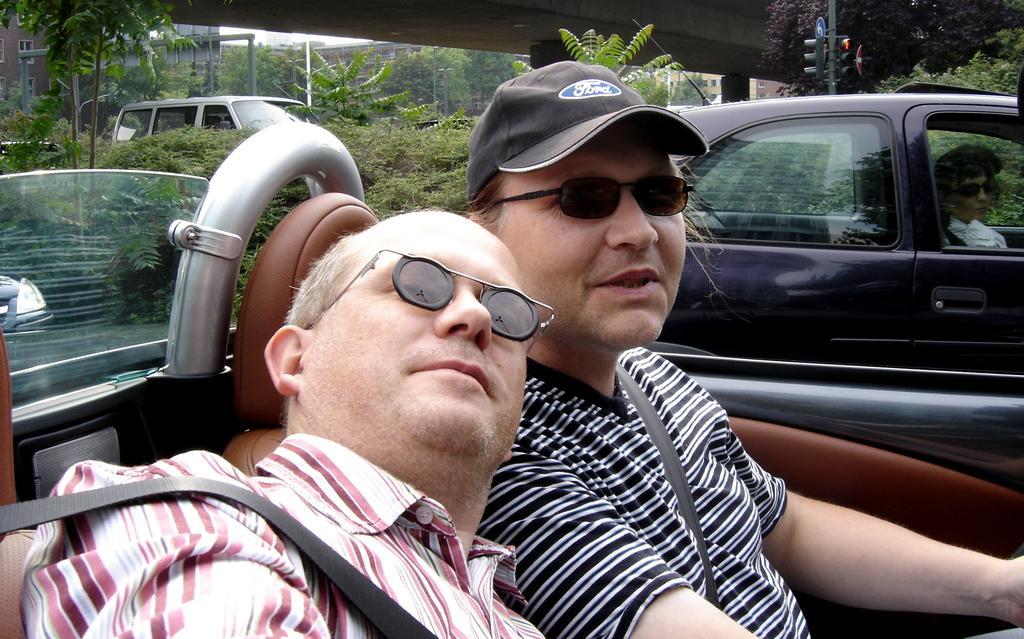Please provide a concise description of this image. In this image there are two persons who are sitting on a vehicle it seems that they are riding a vehicle and on the right side there is one person who is sitting and he is wearing a black shirt and goggles and cap on the left side there is another person who is sitting and he is wearing goggles on the top of the right side of the image there is one car and in that car there is one woman and on the left side of the image there are trees plants buildings and other car is there and on the top of the right side of the image there is one pole and on the top of the image there is one bridge. 